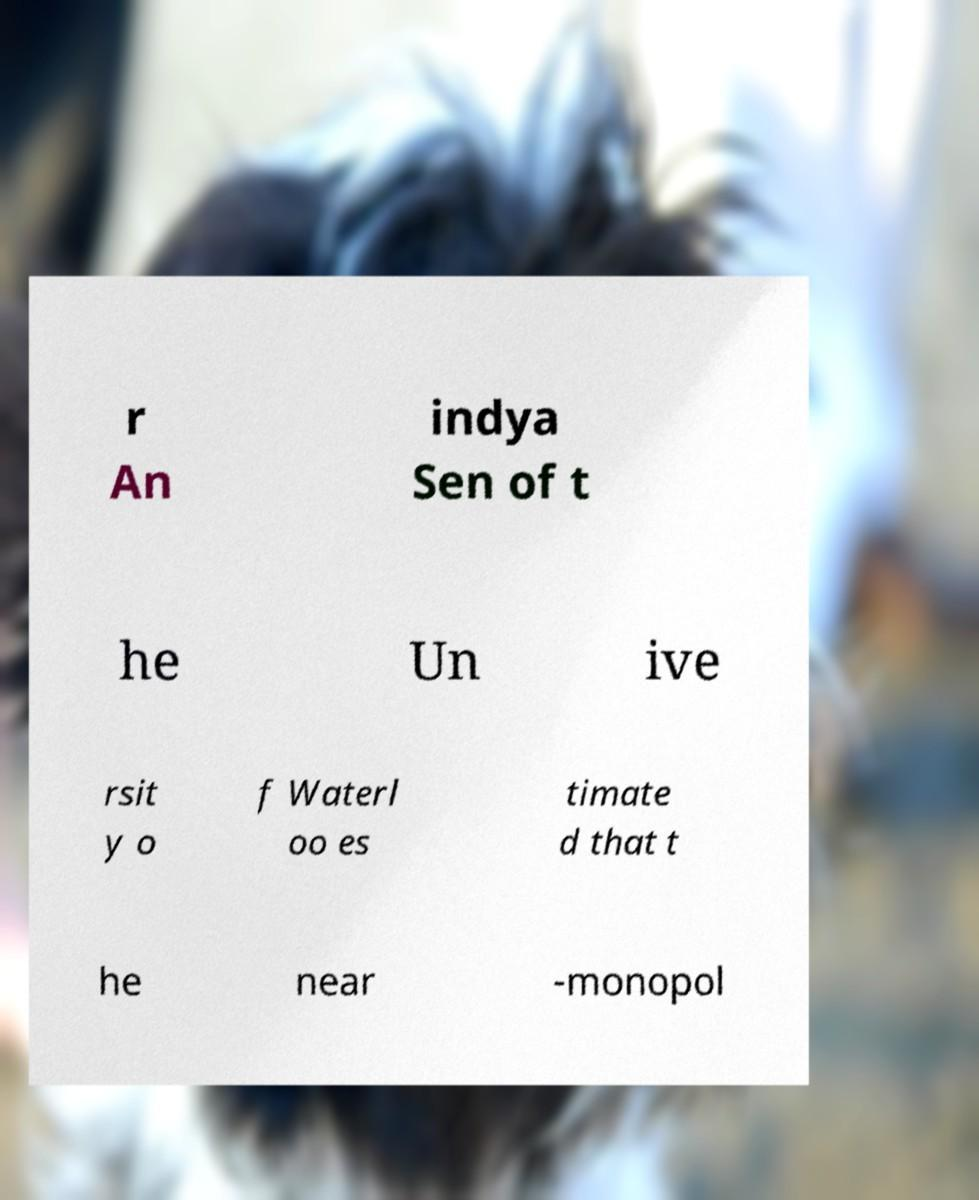For documentation purposes, I need the text within this image transcribed. Could you provide that? r An indya Sen of t he Un ive rsit y o f Waterl oo es timate d that t he near -monopol 